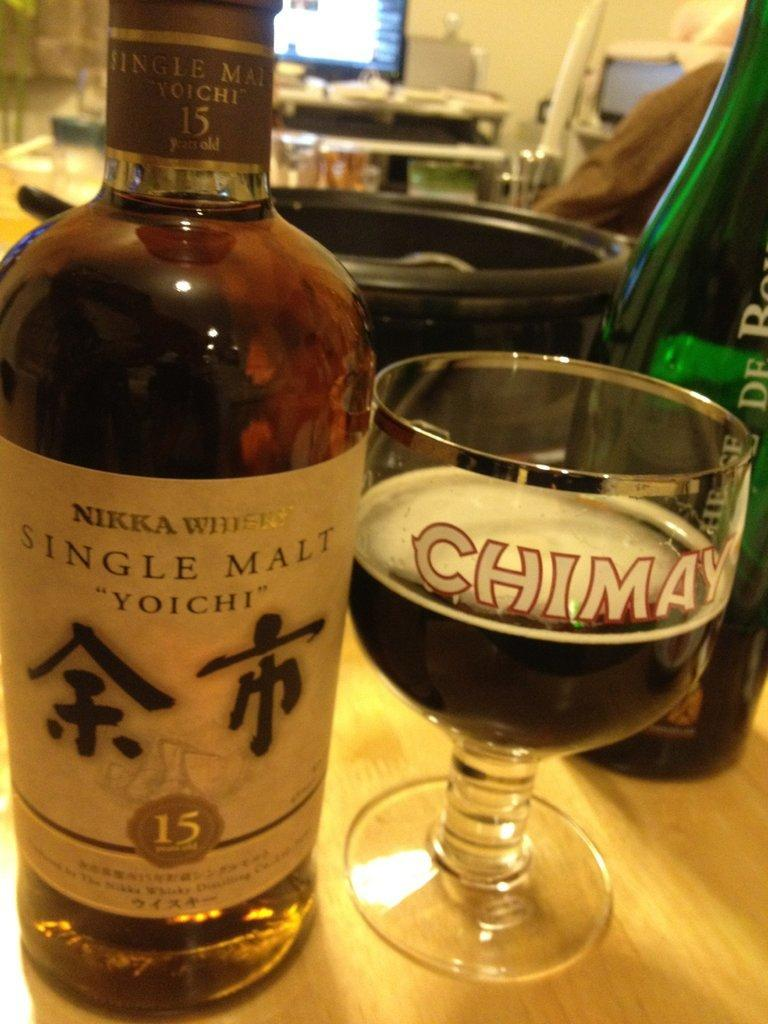What type of glass can be seen in the image? There is a wine glass in the image. What is placed next to the wine glass? There is a wine bottle in the image. Can you describe the wine bottle? The wine bottle has a label. What electronic device is present in the image? There is a TV in the image. Is there a chess game being played on the TV in the image? There is no information about a chess game or any activity on the TV in the image. 